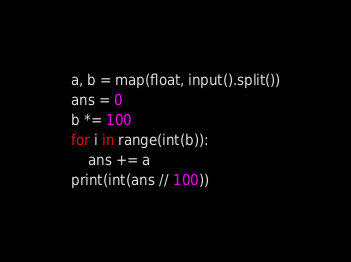<code> <loc_0><loc_0><loc_500><loc_500><_Python_>a, b = map(float, input().split())
ans = 0
b *= 100
for i in range(int(b)):
    ans += a
print(int(ans // 100))</code> 